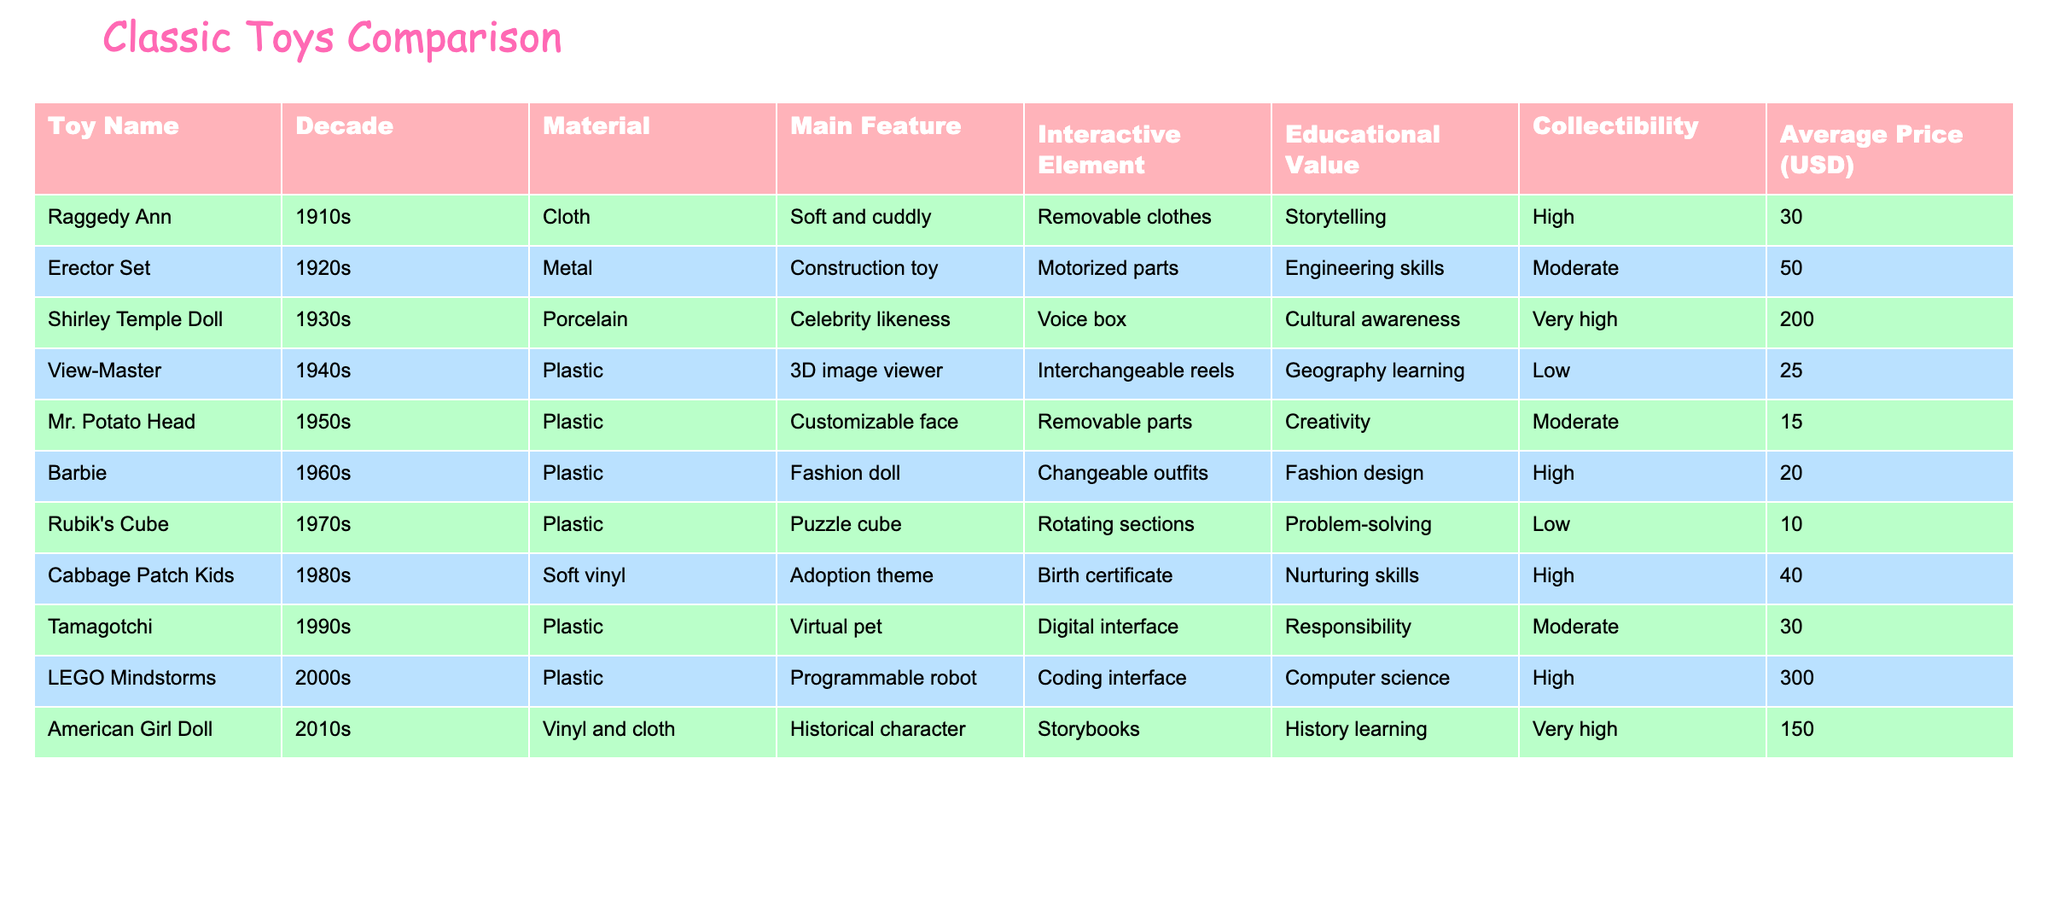What was the most expensive toy in the table? The highest average price listed in the table is for the LEGO Mindstorms at 300 USD. I found this by comparing the prices in the 'Average Price (USD)' column.
Answer: 300 Which decade had the toy with the highest collectibility? The Shirley Temple Doll from the 1930s has the highest collectibility rated as "Very high" compared to others. I determined this by checking the 'Collectibility' column and seeing the rankings.
Answer: 1930s Are there any toys made of cloth in the table? Yes, the Raggedy Ann from the 1910s is the only toy listed that is made of cloth. I looked through the 'Material' column and found it there.
Answer: Yes What toys were created after the 1980s and have educational value? The LEGO Mindstorms from the 2000s and American Girl Doll from the 2010s both have high educational value. I filtered the years from the 'Decade' column and then checked the educational ratings.
Answer: LEGO Mindstorms, American Girl Doll How many toys are made from plastic? There are five toys made from plastic: Erector Set, View-Master, Mr. Potato Head, Barbie, Rubik's Cube, Tamagotchi, and LEGO Mindstorms. I counted the entries in the 'Material' column that listed plastic.
Answer: 6 Which toy has a removable interactive element and what is it? The Mr. Potato Head has removable parts as its interactive element, which I found by looking under the 'Interactive Element' column.
Answer: Mr. Potato Head, removable parts What's the average price of the toys from the 1990s? The average price of the toys from the 1990s (Tamagotchi) is 30 USD, as there's only one toy from that decade. Therefore, the average remains the same as the individual price, which is simply 30 USD.
Answer: 30 Is there a toy that focuses on engineering skills? Yes, the Erector Set from the 1920s focuses on engineering skills, shown in the 'Main Feature' column.
Answer: Yes 